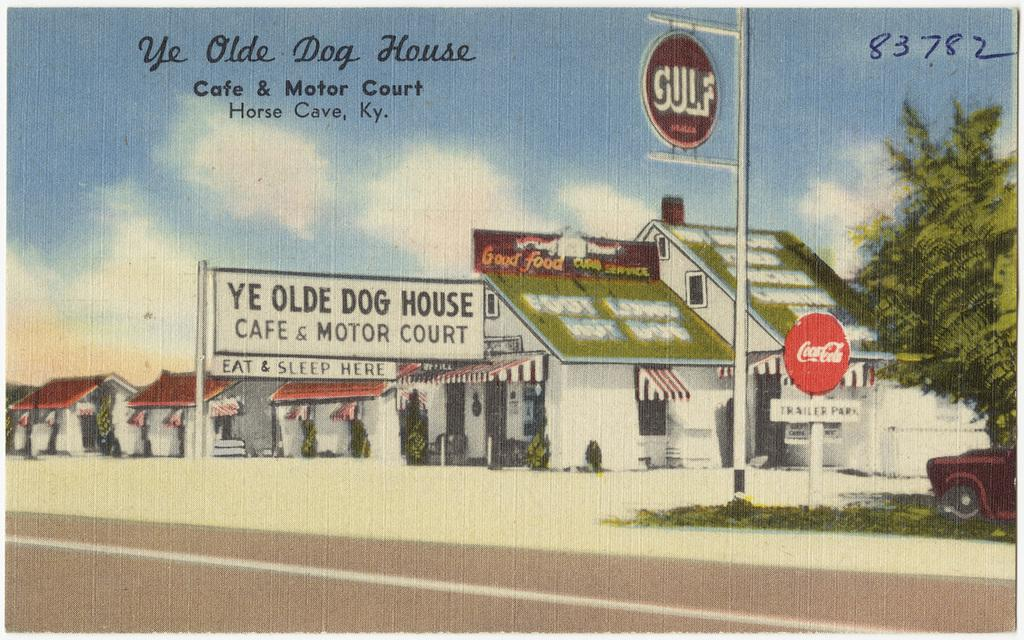<image>
Write a terse but informative summary of the picture. A postcard shows Ye Olde Dog House, which is a cafe and motor court. 